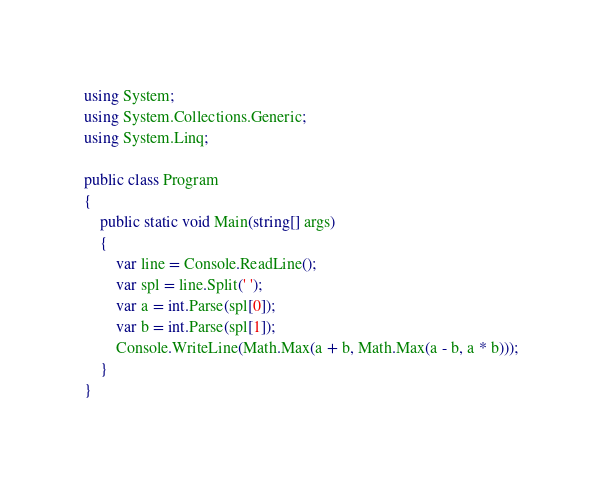<code> <loc_0><loc_0><loc_500><loc_500><_C#_>using System;
using System.Collections.Generic;
using System.Linq;

public class Program
{
    public static void Main(string[] args)
    {
        var line = Console.ReadLine();
        var spl = line.Split(' ');
        var a = int.Parse(spl[0]);
        var b = int.Parse(spl[1]);
        Console.WriteLine(Math.Max(a + b, Math.Max(a - b, a * b)));
    }
}</code> 